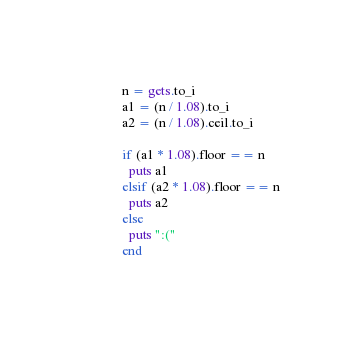<code> <loc_0><loc_0><loc_500><loc_500><_Ruby_>n = gets.to_i
a1 = (n / 1.08).to_i
a2 = (n / 1.08).ceil.to_i

if (a1 * 1.08).floor == n
  puts a1
elsif (a2 * 1.08).floor == n
  puts a2
else
  puts ":("
end</code> 